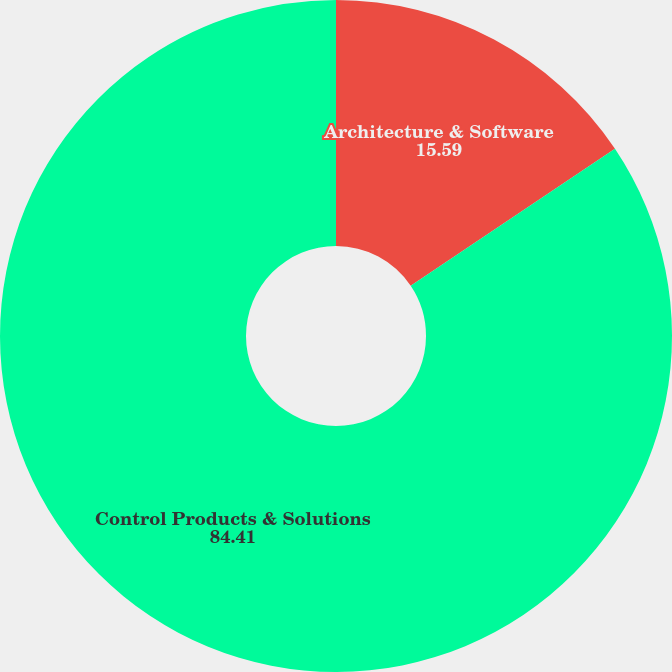<chart> <loc_0><loc_0><loc_500><loc_500><pie_chart><fcel>Architecture & Software<fcel>Control Products & Solutions<nl><fcel>15.59%<fcel>84.41%<nl></chart> 